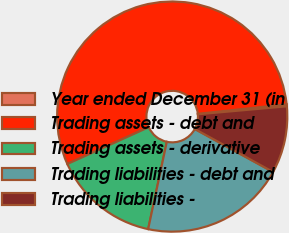<chart> <loc_0><loc_0><loc_500><loc_500><pie_chart><fcel>Year ended December 31 (in<fcel>Trading assets - debt and<fcel>Trading assets - derivative<fcel>Trading liabilities - debt and<fcel>Trading liabilities -<nl><fcel>0.29%<fcel>55.05%<fcel>14.89%<fcel>20.36%<fcel>9.41%<nl></chart> 